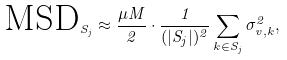Convert formula to latex. <formula><loc_0><loc_0><loc_500><loc_500>\text {MSD} _ { S _ { j } } \approx \frac { \mu M } { 2 } \cdot \frac { 1 } { ( { | S _ { j } | } ) ^ { 2 } } \sum _ { k \in S _ { j } } \sigma _ { v , k } ^ { 2 } ,</formula> 